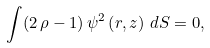<formula> <loc_0><loc_0><loc_500><loc_500>\int ( 2 \, \rho - 1 ) \, { \psi ^ { 2 } \left ( r , z \right ) \, d S } = 0 ,</formula> 